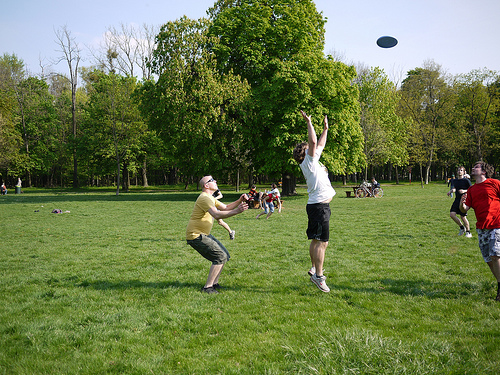Are there any birds in the air? No, there are no birds visible in the air in this image. 